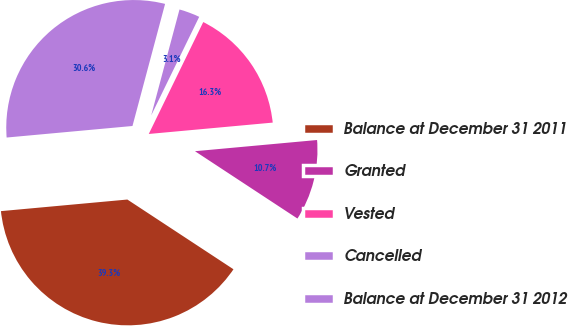<chart> <loc_0><loc_0><loc_500><loc_500><pie_chart><fcel>Balance at December 31 2011<fcel>Granted<fcel>Vested<fcel>Cancelled<fcel>Balance at December 31 2012<nl><fcel>39.29%<fcel>10.71%<fcel>16.33%<fcel>3.06%<fcel>30.61%<nl></chart> 